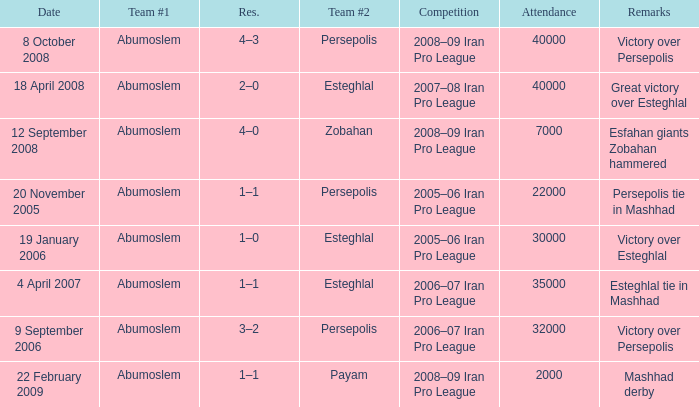What was the largest attendance? 40000.0. 